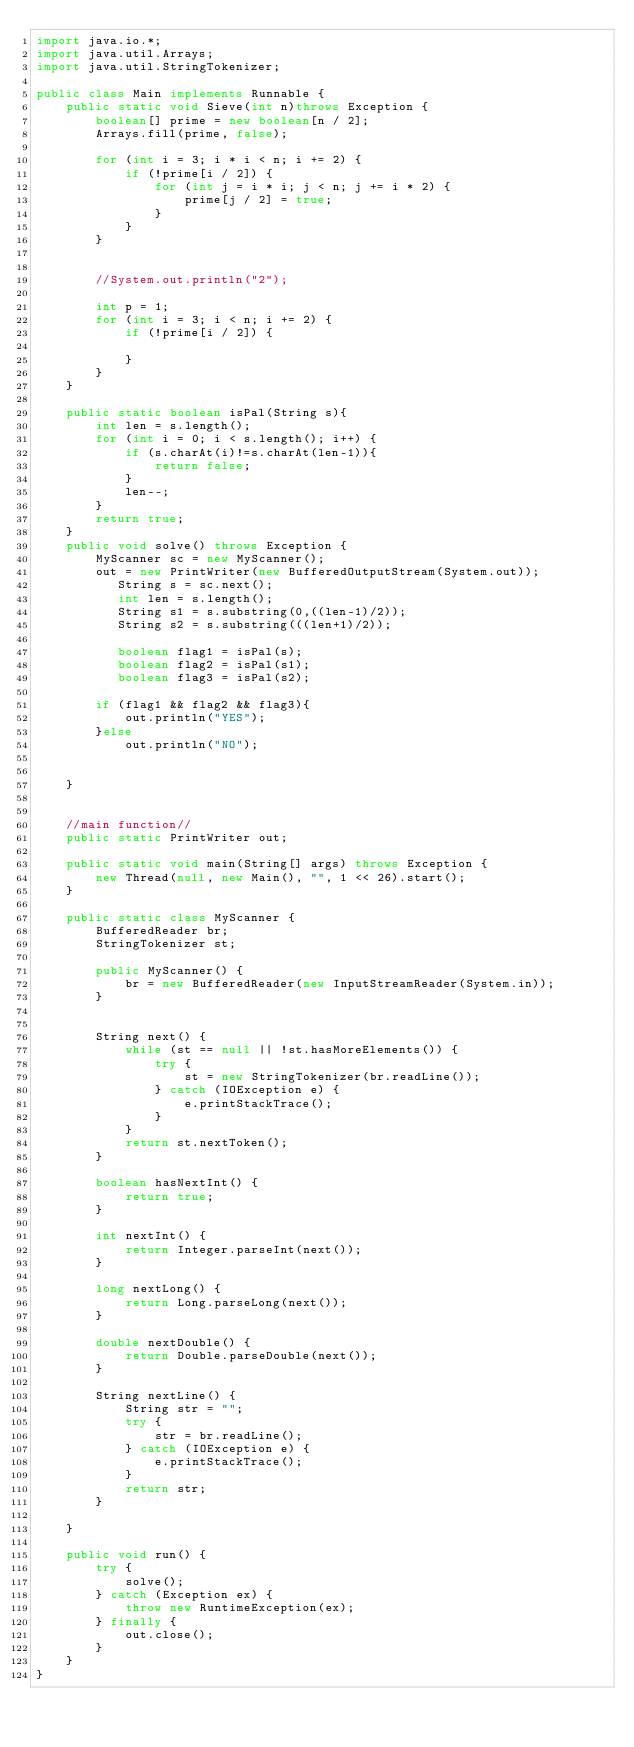<code> <loc_0><loc_0><loc_500><loc_500><_Java_>import java.io.*;
import java.util.Arrays;
import java.util.StringTokenizer;

public class Main implements Runnable {
    public static void Sieve(int n)throws Exception {
        boolean[] prime = new boolean[n / 2];
        Arrays.fill(prime, false);

        for (int i = 3; i * i < n; i += 2) {
            if (!prime[i / 2]) {
                for (int j = i * i; j < n; j += i * 2) {
                    prime[j / 2] = true;
                }
            }
        }


        //System.out.println("2");

        int p = 1;
        for (int i = 3; i < n; i += 2) {
            if (!prime[i / 2]) {

            }
        }
    }

    public static boolean isPal(String s){
        int len = s.length();
        for (int i = 0; i < s.length(); i++) {
            if (s.charAt(i)!=s.charAt(len-1)){
                return false;
            }
            len--;
        }
        return true;
    }
    public void solve() throws Exception {
        MyScanner sc = new MyScanner();
        out = new PrintWriter(new BufferedOutputStream(System.out));
           String s = sc.next();
           int len = s.length();
           String s1 = s.substring(0,((len-1)/2));
           String s2 = s.substring(((len+1)/2));

           boolean flag1 = isPal(s);
           boolean flag2 = isPal(s1);
           boolean flag3 = isPal(s2);

        if (flag1 && flag2 && flag3){
            out.println("YES");
        }else
            out.println("NO");


    }


    //main function//
    public static PrintWriter out;

    public static void main(String[] args) throws Exception {
        new Thread(null, new Main(), "", 1 << 26).start();
    }

    public static class MyScanner {
        BufferedReader br;
        StringTokenizer st;

        public MyScanner() {
            br = new BufferedReader(new InputStreamReader(System.in));
        }


        String next() {
            while (st == null || !st.hasMoreElements()) {
                try {
                    st = new StringTokenizer(br.readLine());
                } catch (IOException e) {
                    e.printStackTrace();
                }
            }
            return st.nextToken();
        }

        boolean hasNextInt() {
            return true;
        }

        int nextInt() {
            return Integer.parseInt(next());
        }

        long nextLong() {
            return Long.parseLong(next());
        }

        double nextDouble() {
            return Double.parseDouble(next());
        }

        String nextLine() {
            String str = "";
            try {
                str = br.readLine();
            } catch (IOException e) {
                e.printStackTrace();
            }
            return str;
        }

    }

    public void run() {
        try {
            solve();
        } catch (Exception ex) {
            throw new RuntimeException(ex);
        } finally {
            out.close();
        }
    }
}</code> 